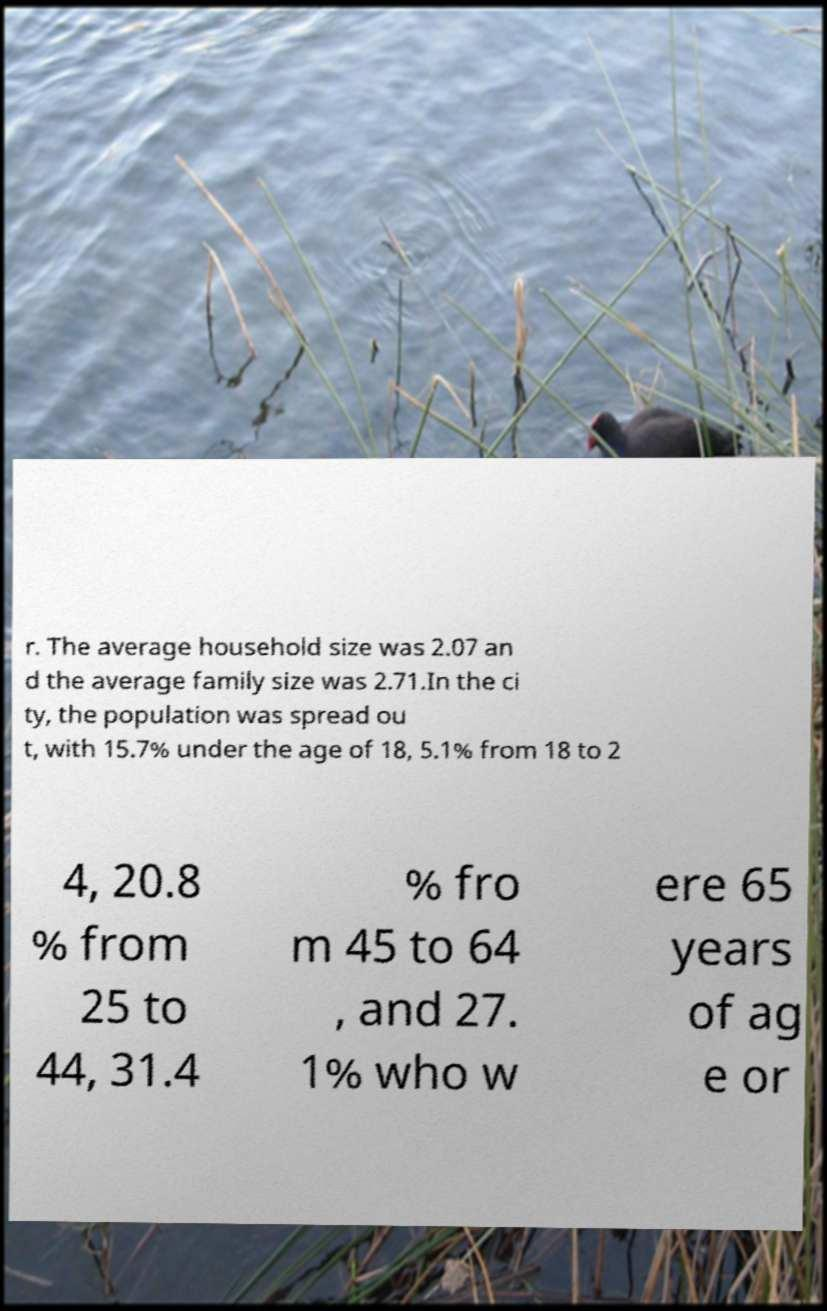Please read and relay the text visible in this image. What does it say? r. The average household size was 2.07 an d the average family size was 2.71.In the ci ty, the population was spread ou t, with 15.7% under the age of 18, 5.1% from 18 to 2 4, 20.8 % from 25 to 44, 31.4 % fro m 45 to 64 , and 27. 1% who w ere 65 years of ag e or 